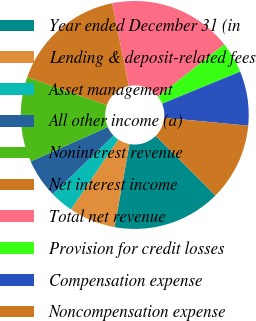Convert chart. <chart><loc_0><loc_0><loc_500><loc_500><pie_chart><fcel>Year ended December 31 (in<fcel>Lending & deposit-related fees<fcel>Asset management<fcel>All other income (a)<fcel>Noninterest revenue<fcel>Net interest income<fcel>Total net revenue<fcel>Provision for credit losses<fcel>Compensation expense<fcel>Noncompensation expense<nl><fcel>15.36%<fcel>6.61%<fcel>3.33%<fcel>5.52%<fcel>12.08%<fcel>16.45%<fcel>17.55%<fcel>4.42%<fcel>7.7%<fcel>10.98%<nl></chart> 